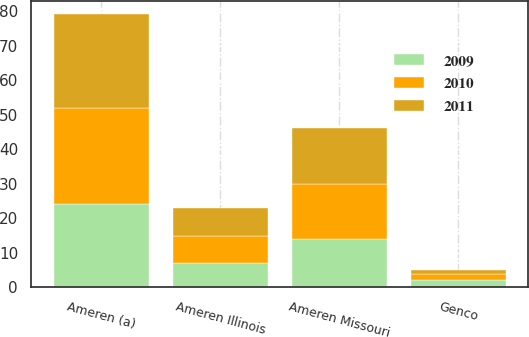<chart> <loc_0><loc_0><loc_500><loc_500><stacked_bar_chart><ecel><fcel>Ameren (a)<fcel>Ameren Missouri<fcel>Ameren Illinois<fcel>Genco<nl><fcel>2010<fcel>28<fcel>16<fcel>8<fcel>2<nl><fcel>2011<fcel>27<fcel>16<fcel>8<fcel>1<nl><fcel>2009<fcel>24<fcel>14<fcel>7<fcel>2<nl></chart> 